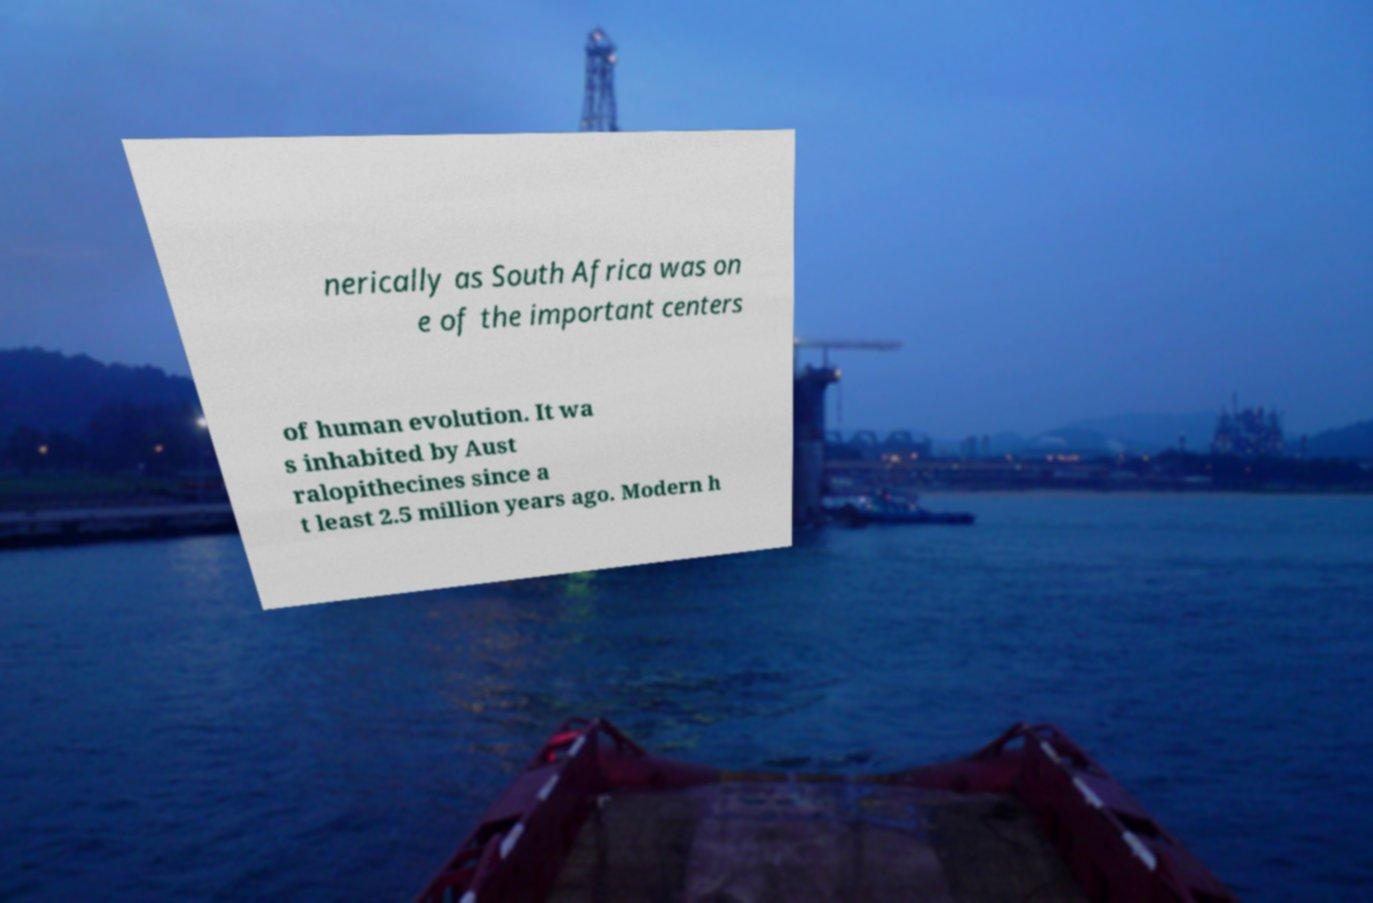For documentation purposes, I need the text within this image transcribed. Could you provide that? nerically as South Africa was on e of the important centers of human evolution. It wa s inhabited by Aust ralopithecines since a t least 2.5 million years ago. Modern h 